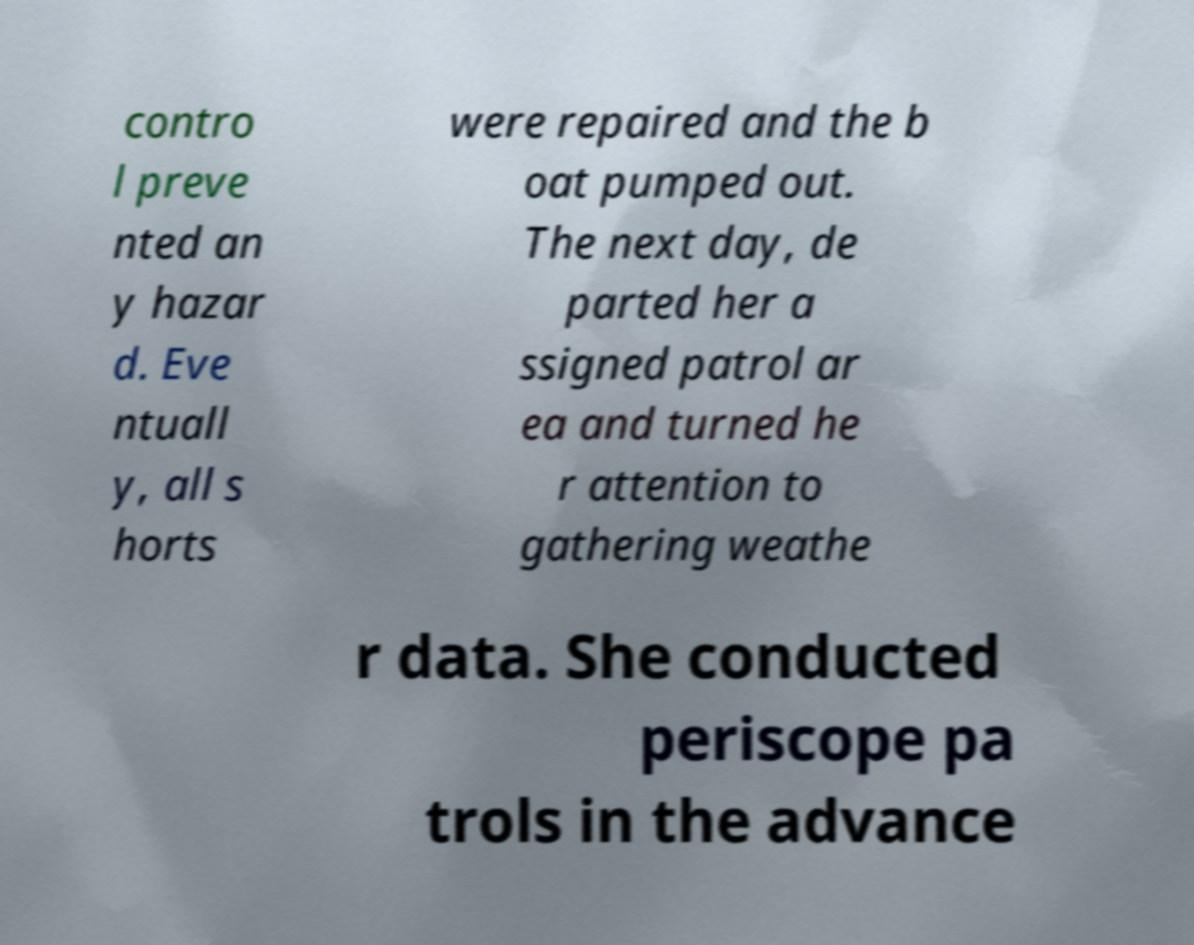Could you extract and type out the text from this image? contro l preve nted an y hazar d. Eve ntuall y, all s horts were repaired and the b oat pumped out. The next day, de parted her a ssigned patrol ar ea and turned he r attention to gathering weathe r data. She conducted periscope pa trols in the advance 